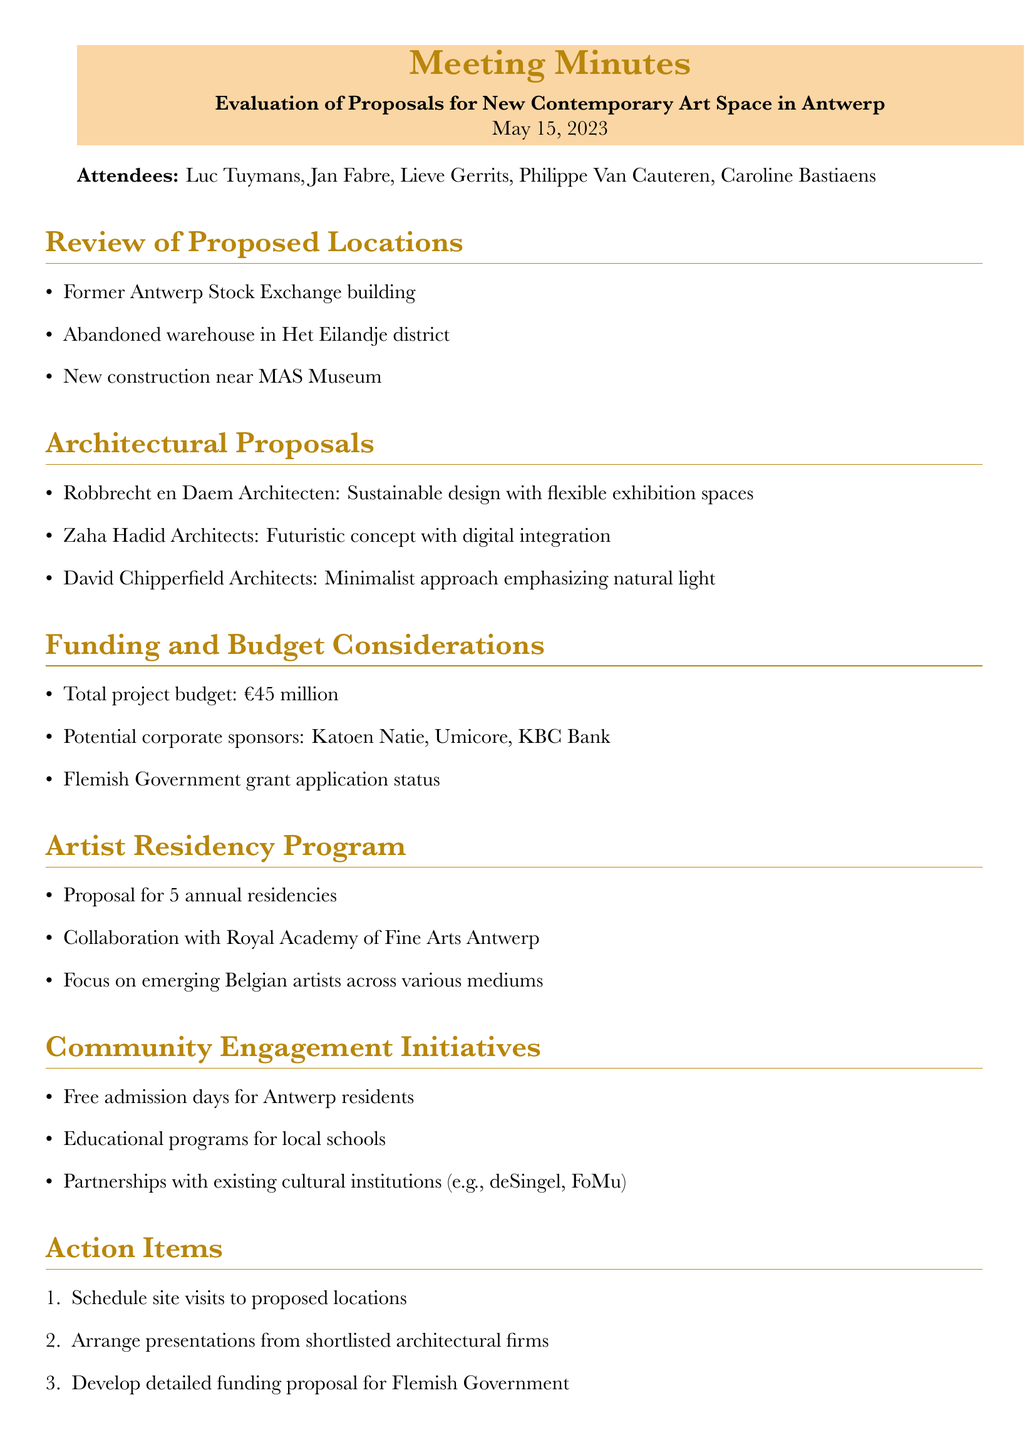What is the date of the meeting? The date of the meeting is specified in the document header.
Answer: May 15, 2023 Who is the Alderwoman of Culture? The document lists attendees, including the Alderwoman of Culture.
Answer: Caroline Bastiaens What is the total project budget? The budget is explicitly stated in the funding and budget considerations section.
Answer: €45 million How many annual residencies are proposed? This information can be found in the artist residency program section.
Answer: 5 annual residencies What is one proposed location for the new contemporary art space? The document outlines various proposed locations, from which one can be selected.
Answer: Former Antwerp Stock Exchange building Which architectural firm proposed a sustainable design? The architectural proposals section specifies different firms and their concepts.
Answer: Robbrecht en Daem Architecten What is one community engagement initiative mentioned? The document provides specific points under the community engagement initiatives.
Answer: Free admission days for Antwerp residents When is the next meeting scheduled? The next meeting date is provided at the end of the document.
Answer: June 1, 2023 